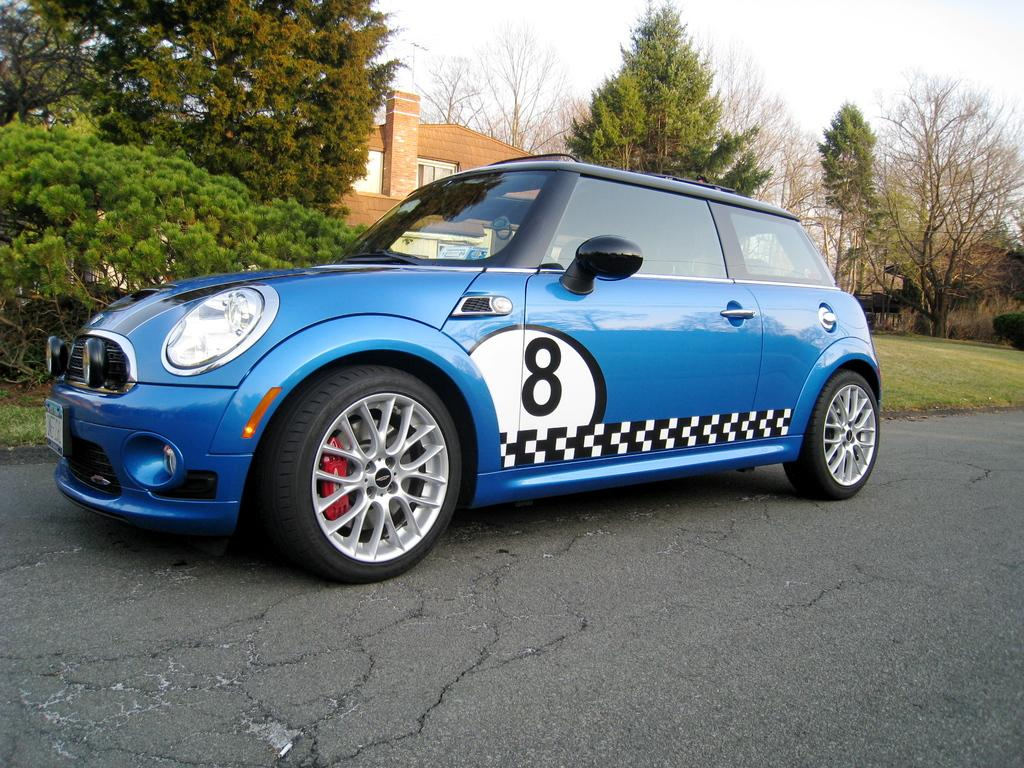What is the main subject of the image? There is a car on the road in the image. What can be seen in the background of the image? There are trees and a building in the image. What is the condition of the sky in the image? The sky is cloudy in the image. What type of vegetation is visible on the ground in the image? There is grass visible on the ground in the image. What type of pie is being served on the table in the image? There is no table or pie present in the image; it features a car on the road with trees, a building, a cloudy sky, and grass on the ground. Can you tell me how many quills are visible in the image? There are no quills present in the image. 